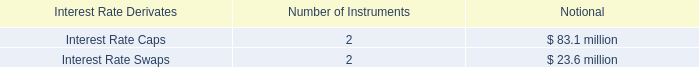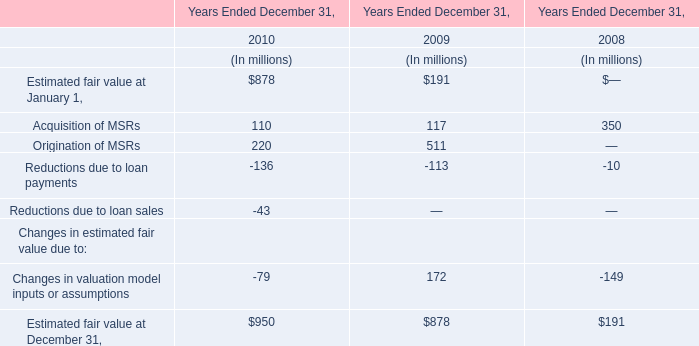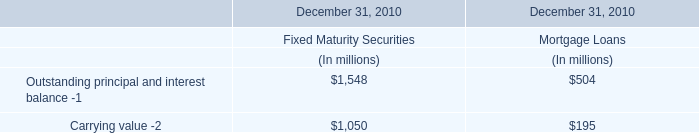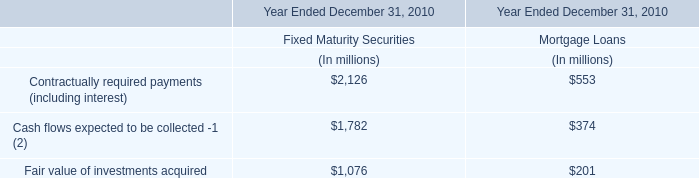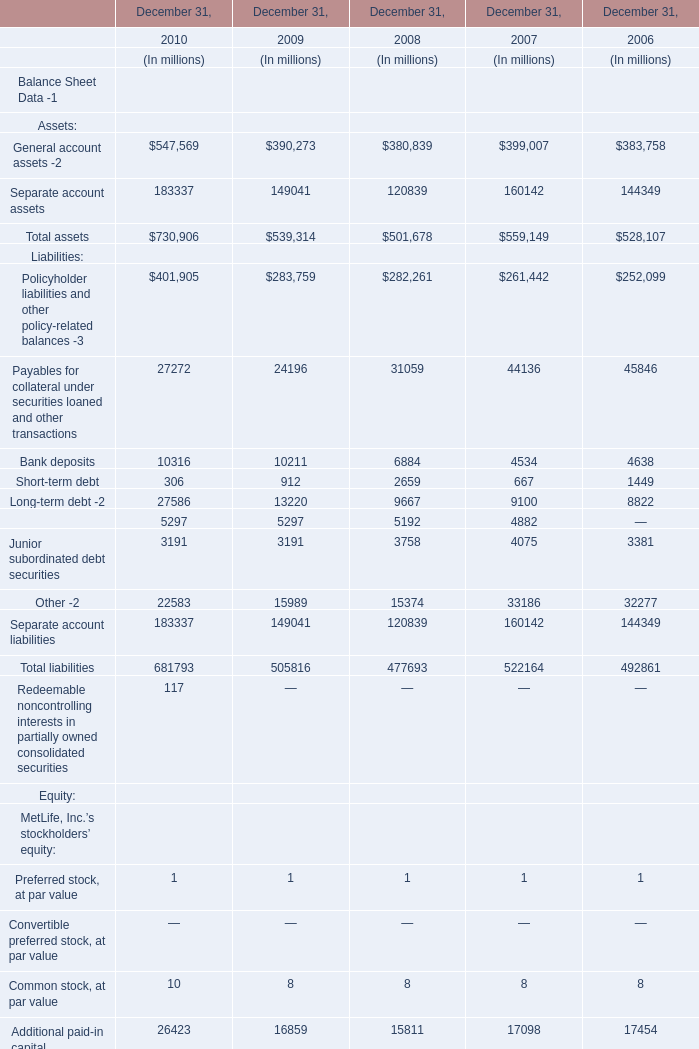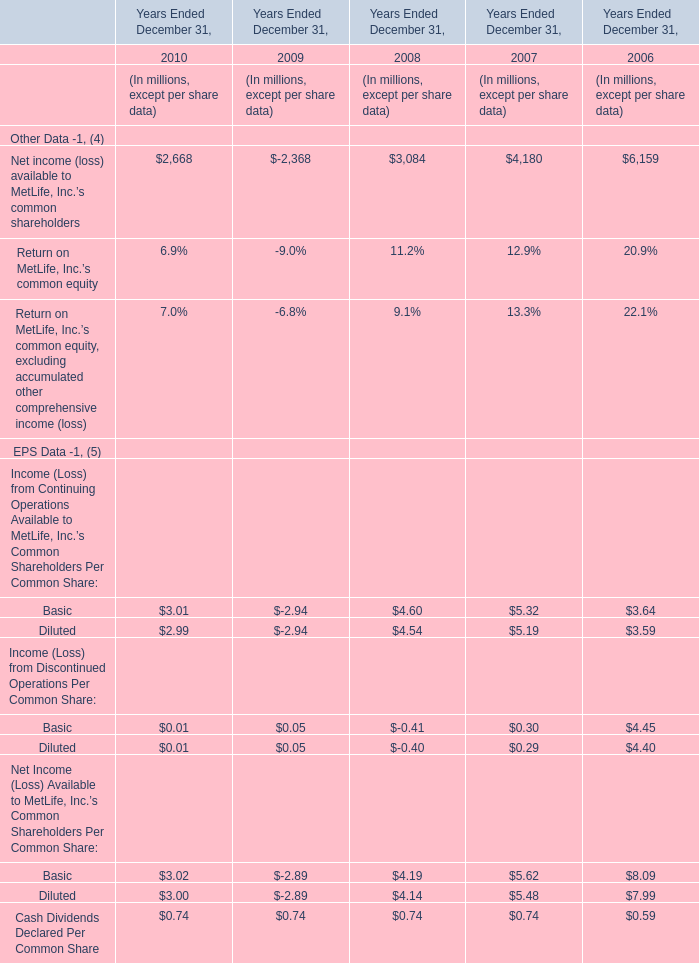What was the average of Total assets in 2010,2009 and 2008 ? 
Computations: (((730906 + 539314) + 501678) / 3)
Answer: 590632.66667. 